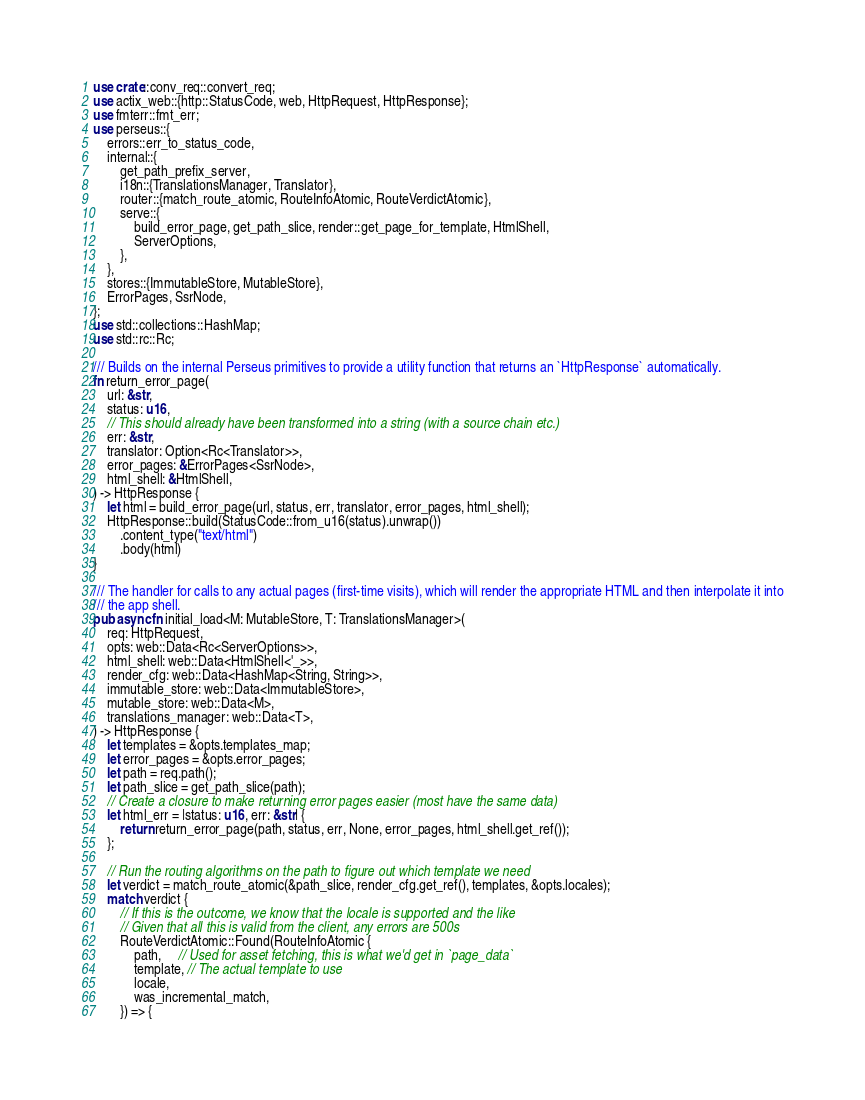Convert code to text. <code><loc_0><loc_0><loc_500><loc_500><_Rust_>use crate::conv_req::convert_req;
use actix_web::{http::StatusCode, web, HttpRequest, HttpResponse};
use fmterr::fmt_err;
use perseus::{
    errors::err_to_status_code,
    internal::{
        get_path_prefix_server,
        i18n::{TranslationsManager, Translator},
        router::{match_route_atomic, RouteInfoAtomic, RouteVerdictAtomic},
        serve::{
            build_error_page, get_path_slice, render::get_page_for_template, HtmlShell,
            ServerOptions,
        },
    },
    stores::{ImmutableStore, MutableStore},
    ErrorPages, SsrNode,
};
use std::collections::HashMap;
use std::rc::Rc;

/// Builds on the internal Perseus primitives to provide a utility function that returns an `HttpResponse` automatically.
fn return_error_page(
    url: &str,
    status: u16,
    // This should already have been transformed into a string (with a source chain etc.)
    err: &str,
    translator: Option<Rc<Translator>>,
    error_pages: &ErrorPages<SsrNode>,
    html_shell: &HtmlShell,
) -> HttpResponse {
    let html = build_error_page(url, status, err, translator, error_pages, html_shell);
    HttpResponse::build(StatusCode::from_u16(status).unwrap())
        .content_type("text/html")
        .body(html)
}

/// The handler for calls to any actual pages (first-time visits), which will render the appropriate HTML and then interpolate it into
/// the app shell.
pub async fn initial_load<M: MutableStore, T: TranslationsManager>(
    req: HttpRequest,
    opts: web::Data<Rc<ServerOptions>>,
    html_shell: web::Data<HtmlShell<'_>>,
    render_cfg: web::Data<HashMap<String, String>>,
    immutable_store: web::Data<ImmutableStore>,
    mutable_store: web::Data<M>,
    translations_manager: web::Data<T>,
) -> HttpResponse {
    let templates = &opts.templates_map;
    let error_pages = &opts.error_pages;
    let path = req.path();
    let path_slice = get_path_slice(path);
    // Create a closure to make returning error pages easier (most have the same data)
    let html_err = |status: u16, err: &str| {
        return return_error_page(path, status, err, None, error_pages, html_shell.get_ref());
    };

    // Run the routing algorithms on the path to figure out which template we need
    let verdict = match_route_atomic(&path_slice, render_cfg.get_ref(), templates, &opts.locales);
    match verdict {
        // If this is the outcome, we know that the locale is supported and the like
        // Given that all this is valid from the client, any errors are 500s
        RouteVerdictAtomic::Found(RouteInfoAtomic {
            path,     // Used for asset fetching, this is what we'd get in `page_data`
            template, // The actual template to use
            locale,
            was_incremental_match,
        }) => {</code> 